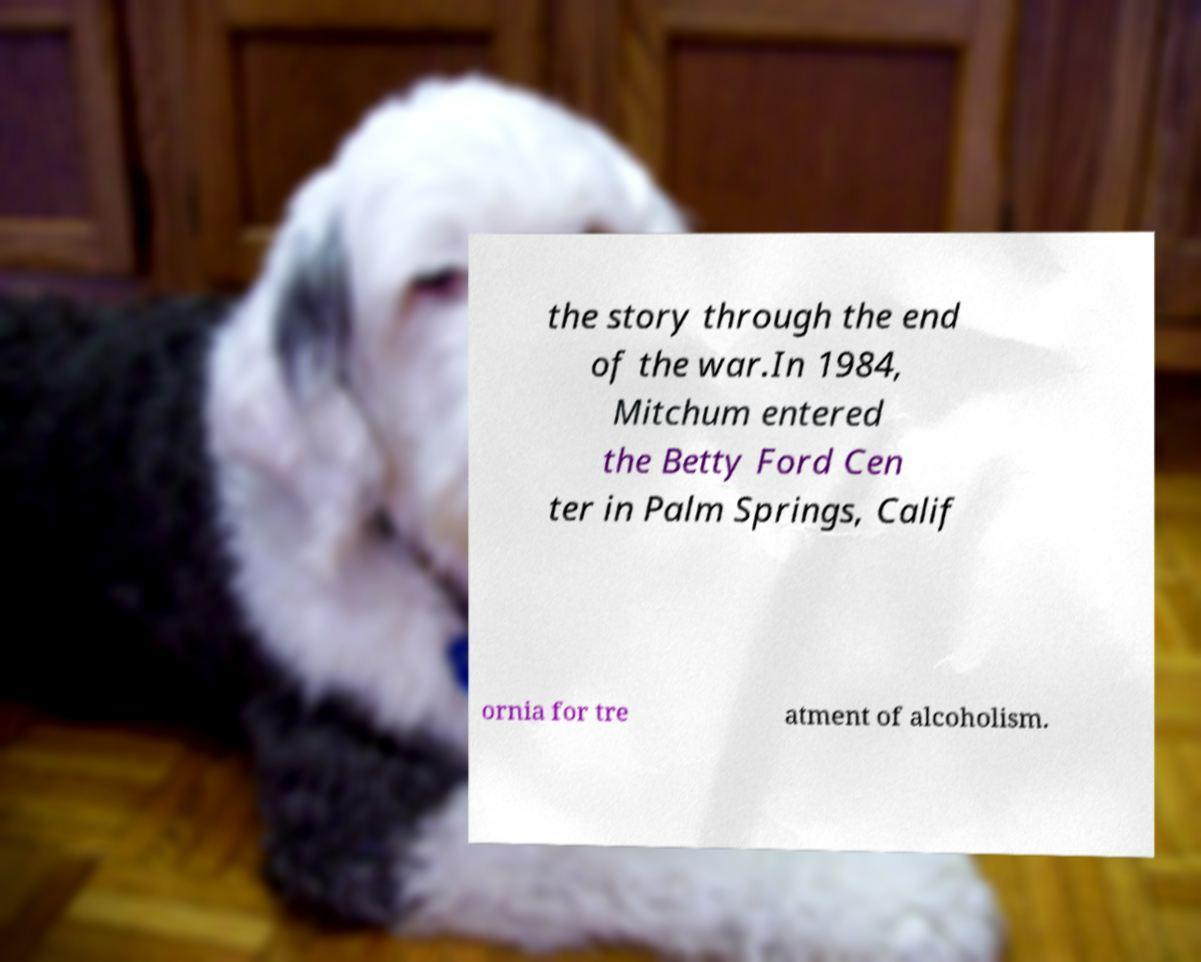Can you read and provide the text displayed in the image?This photo seems to have some interesting text. Can you extract and type it out for me? the story through the end of the war.In 1984, Mitchum entered the Betty Ford Cen ter in Palm Springs, Calif ornia for tre atment of alcoholism. 